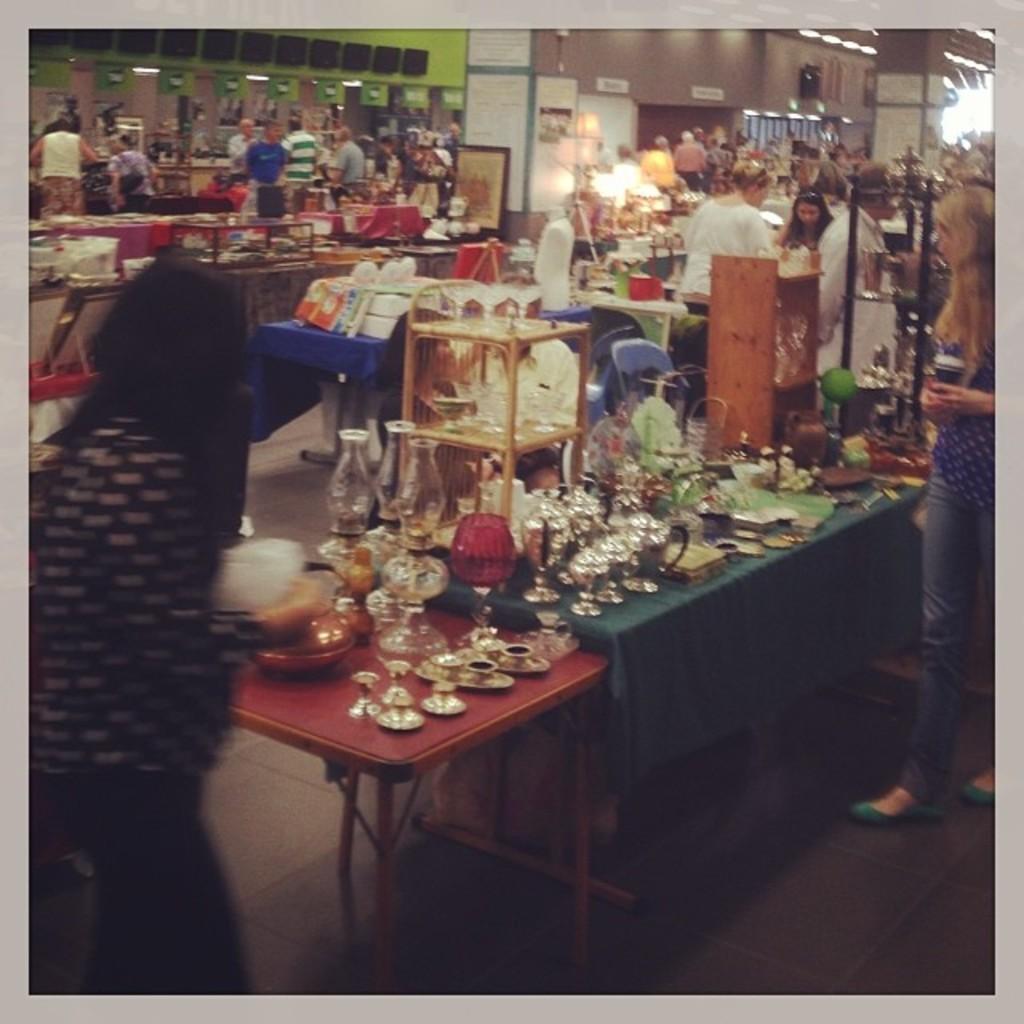Could you give a brief overview of what you see in this image? In this picture we can see a group of people standing and looking at the items on table such as lamp, shields, steel and in background we can see wall, pillar. 